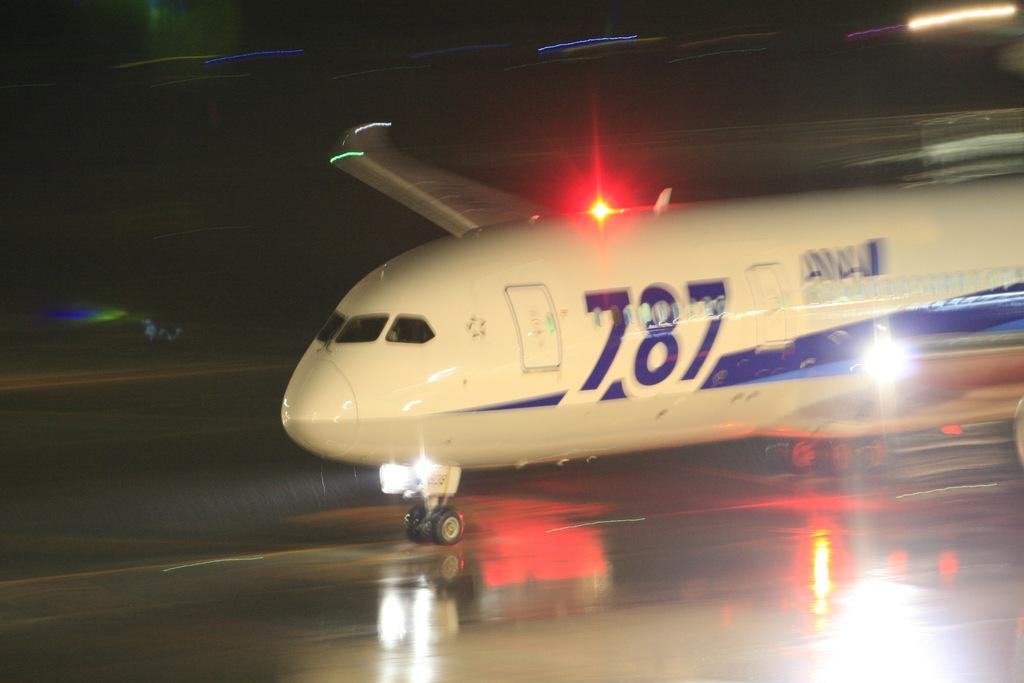What is the main subject of the image? There is an aeroplane in the center of the image. What can be seen in the background of the image? There are lights in the background of the image. What is visible at the bottom of the image? There is a floor visible at the bottom of the image. What type of battle is taking place in the image? There is no battle present in the image; it features an aeroplane and lights in the background. How many birds are in the flock flying above the aeroplane in the image? There are no birds or flock present in the image. 